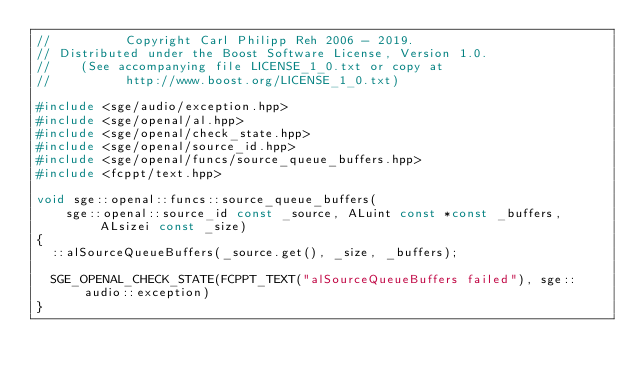<code> <loc_0><loc_0><loc_500><loc_500><_C++_>//          Copyright Carl Philipp Reh 2006 - 2019.
// Distributed under the Boost Software License, Version 1.0.
//    (See accompanying file LICENSE_1_0.txt or copy at
//          http://www.boost.org/LICENSE_1_0.txt)

#include <sge/audio/exception.hpp>
#include <sge/openal/al.hpp>
#include <sge/openal/check_state.hpp>
#include <sge/openal/source_id.hpp>
#include <sge/openal/funcs/source_queue_buffers.hpp>
#include <fcppt/text.hpp>

void sge::openal::funcs::source_queue_buffers(
    sge::openal::source_id const _source, ALuint const *const _buffers, ALsizei const _size)
{
  ::alSourceQueueBuffers(_source.get(), _size, _buffers);

  SGE_OPENAL_CHECK_STATE(FCPPT_TEXT("alSourceQueueBuffers failed"), sge::audio::exception)
}
</code> 